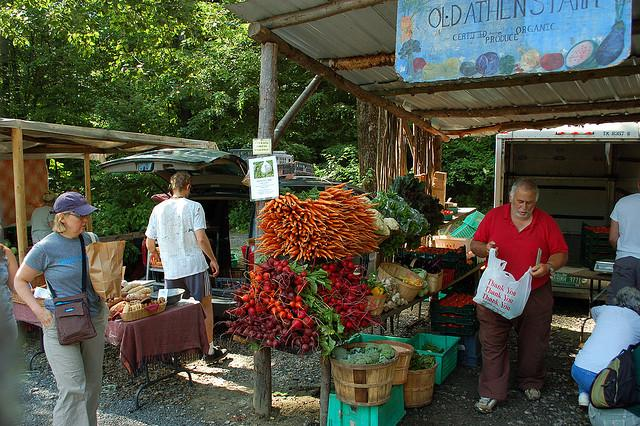Beta carotene rich vegetable in the image is? Please explain your reasoning. carrot. The carrots have beta carotene. 